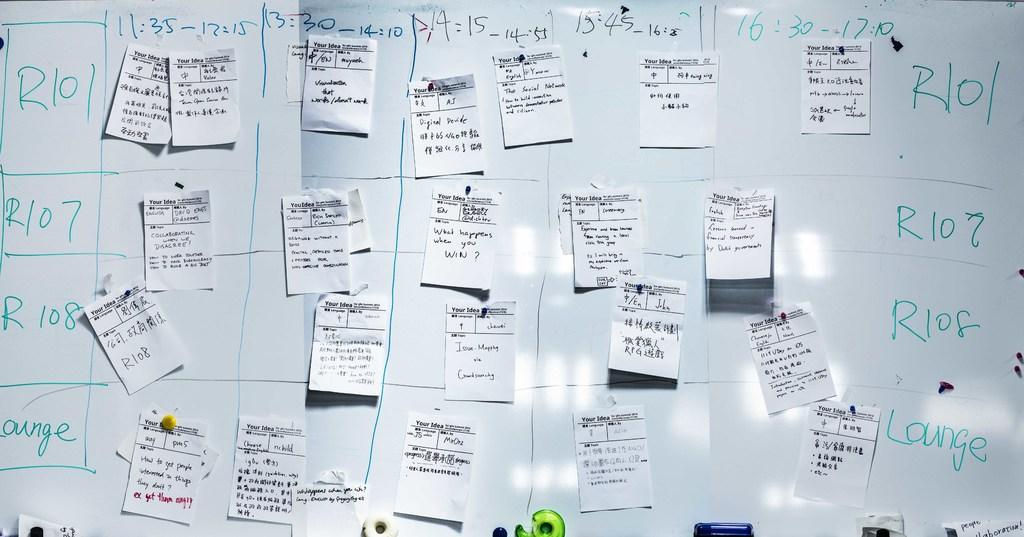What is the main object in the image? There is a board in the image. What is attached to the board? There are papers pasted on the board. Is there any text or information on the board? Yes, there is writing on the board. How many nuts are placed on the board in the image? There are no nuts visible on the board in the image. 